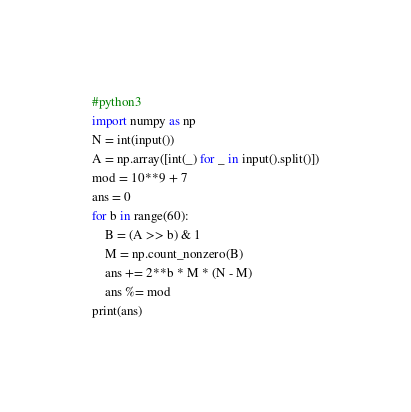<code> <loc_0><loc_0><loc_500><loc_500><_Python_>#python3
import numpy as np
N = int(input())
A = np.array([int(_) for _ in input().split()])
mod = 10**9 + 7
ans = 0
for b in range(60):
    B = (A >> b) & 1
    M = np.count_nonzero(B)
    ans += 2**b * M * (N - M)
    ans %= mod
print(ans)
</code> 